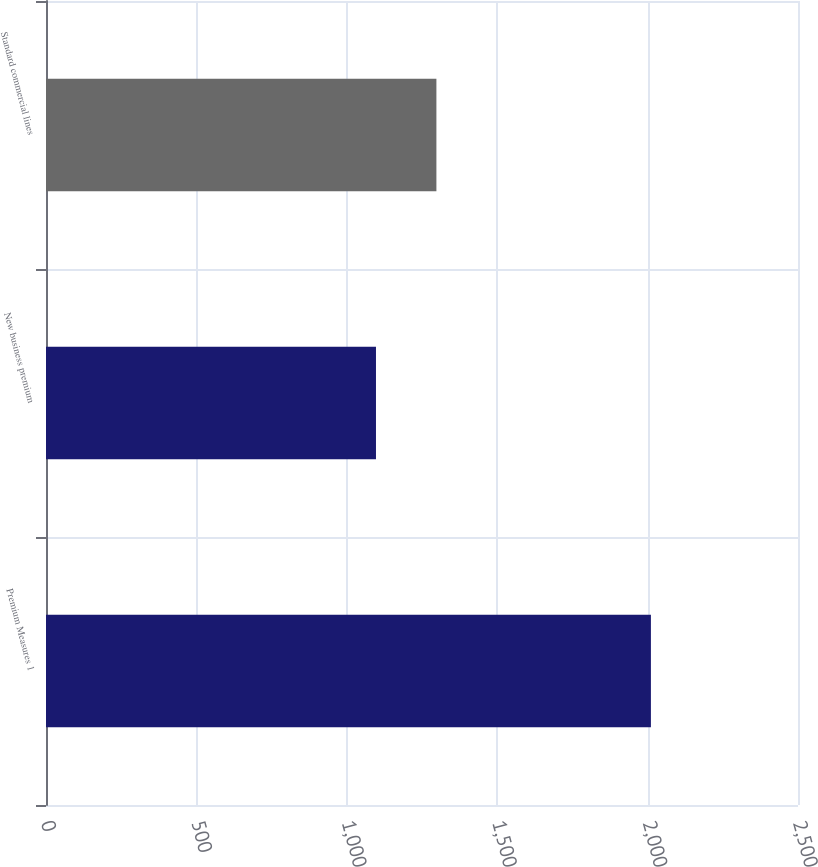Convert chart. <chart><loc_0><loc_0><loc_500><loc_500><bar_chart><fcel>Premium Measures 1<fcel>New business premium<fcel>Standard commercial lines<nl><fcel>2011<fcel>1097<fcel>1297.9<nl></chart> 